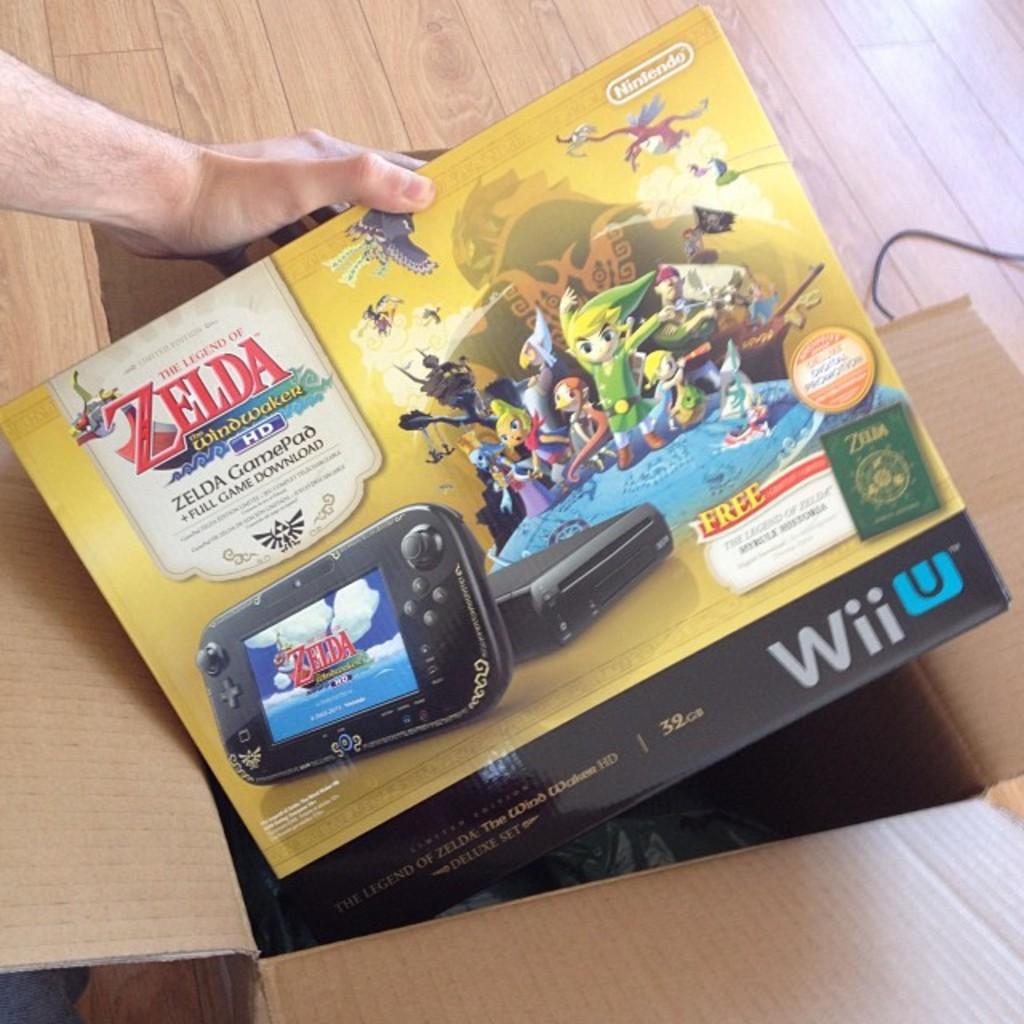What company is this by?
Offer a very short reply. Nintendo. What is the game that is included?
Provide a short and direct response. Zelda. 